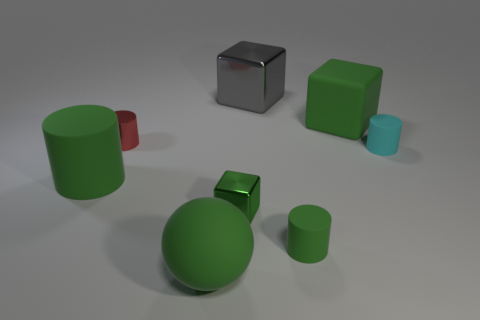There is a matte thing on the left side of the small metallic cylinder in front of the green rubber block; what color is it?
Make the answer very short. Green. How many small objects are either yellow matte blocks or red objects?
Offer a terse response. 1. What color is the cylinder that is both in front of the metal cylinder and to the left of the big green rubber sphere?
Keep it short and to the point. Green. Are the small green cylinder and the big gray thing made of the same material?
Ensure brevity in your answer.  No. What is the shape of the tiny red object?
Give a very brief answer. Cylinder. What number of small rubber objects are to the left of the green cylinder in front of the rubber cylinder that is left of the gray block?
Your response must be concise. 0. What color is the rubber object that is the same shape as the green metallic thing?
Provide a succinct answer. Green. There is a green object right of the green rubber cylinder right of the metallic cube that is to the right of the tiny block; what is its shape?
Keep it short and to the point. Cube. There is a thing that is behind the cyan matte cylinder and to the left of the big green sphere; what size is it?
Your answer should be very brief. Small. Is the number of big matte blocks less than the number of green matte cylinders?
Your answer should be very brief. Yes. 